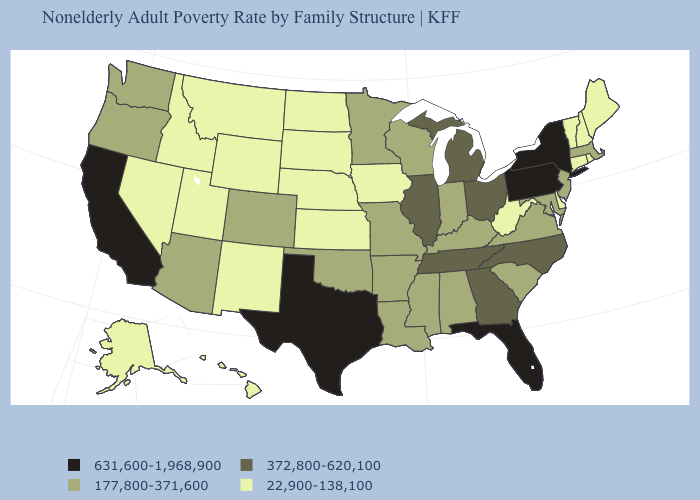Which states hav the highest value in the MidWest?
Give a very brief answer. Illinois, Michigan, Ohio. Among the states that border Florida , which have the lowest value?
Give a very brief answer. Alabama. Which states have the lowest value in the USA?
Be succinct. Alaska, Connecticut, Delaware, Hawaii, Idaho, Iowa, Kansas, Maine, Montana, Nebraska, Nevada, New Hampshire, New Mexico, North Dakota, Rhode Island, South Dakota, Utah, Vermont, West Virginia, Wyoming. Does the map have missing data?
Keep it brief. No. Among the states that border Virginia , which have the lowest value?
Keep it brief. West Virginia. What is the value of Utah?
Keep it brief. 22,900-138,100. What is the value of Texas?
Give a very brief answer. 631,600-1,968,900. Does Hawaii have the lowest value in the USA?
Concise answer only. Yes. How many symbols are there in the legend?
Give a very brief answer. 4. Does Wyoming have the lowest value in the West?
Quick response, please. Yes. Does Delaware have a lower value than Colorado?
Be succinct. Yes. What is the value of Oregon?
Short answer required. 177,800-371,600. What is the value of Indiana?
Give a very brief answer. 177,800-371,600. Which states have the lowest value in the South?
Keep it brief. Delaware, West Virginia. Does the first symbol in the legend represent the smallest category?
Be succinct. No. 